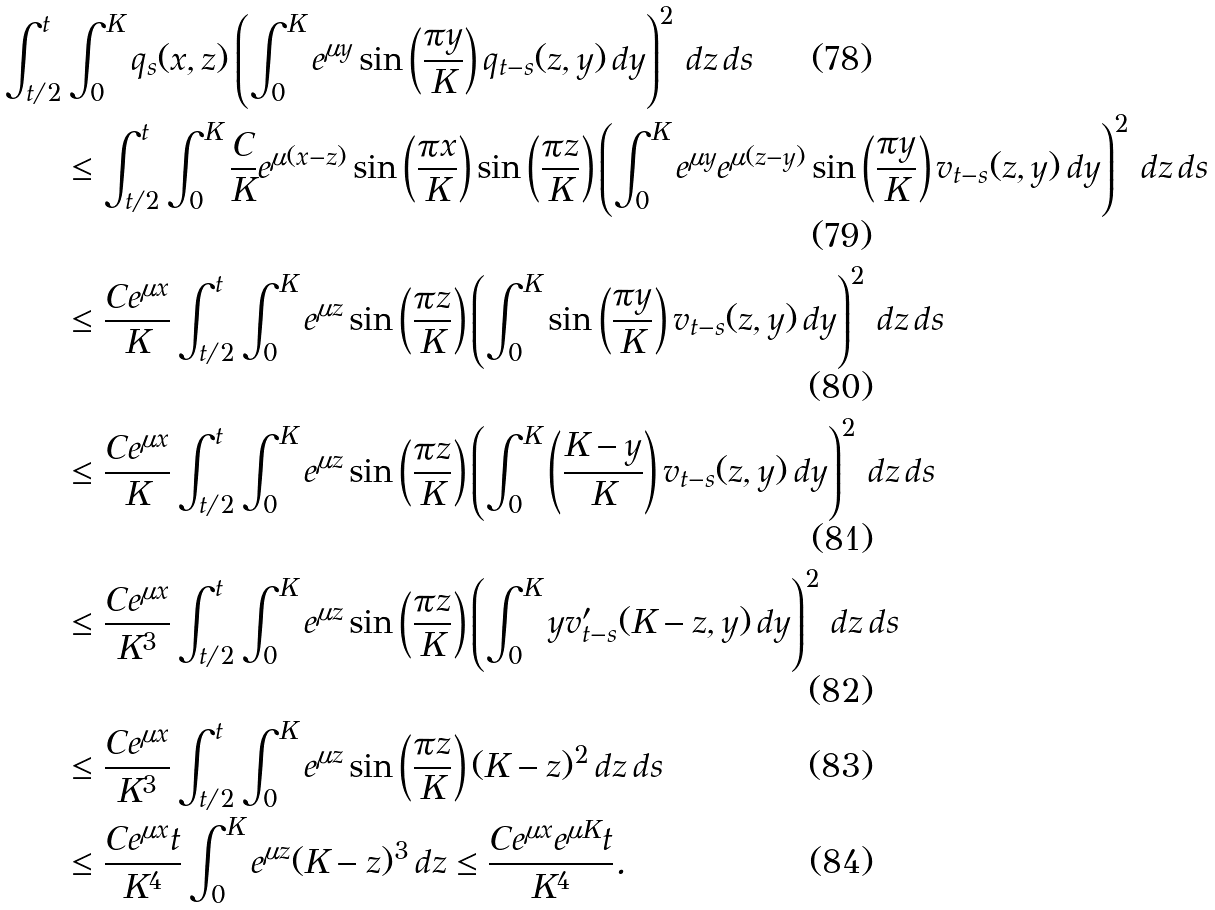Convert formula to latex. <formula><loc_0><loc_0><loc_500><loc_500>\int _ { t / 2 } ^ { t } & \int _ { 0 } ^ { K } q _ { s } ( x , z ) \left ( \int _ { 0 } ^ { K } e ^ { \mu y } \sin \left ( \frac { \pi y } { K } \right ) q _ { t - s } ( z , y ) \, d y \right ) ^ { 2 } \, d z \, d s \\ & \leq \int _ { t / 2 } ^ { t } \int _ { 0 } ^ { K } \frac { C } { K } e ^ { \mu ( x - z ) } \sin \left ( \frac { \pi x } { K } \right ) \sin \left ( \frac { \pi z } { K } \right ) \left ( \int _ { 0 } ^ { K } e ^ { \mu y } e ^ { \mu ( z - y ) } \sin \left ( \frac { \pi y } { K } \right ) v _ { t - s } ( z , y ) \, d y \right ) ^ { 2 } \, d z \, d s \\ & \leq \frac { C e ^ { \mu x } } { K } \int _ { t / 2 } ^ { t } \int _ { 0 } ^ { K } e ^ { \mu z } \sin \left ( \frac { \pi z } { K } \right ) \left ( \int _ { 0 } ^ { K } \sin \left ( \frac { \pi y } { K } \right ) v _ { t - s } ( z , y ) \, d y \right ) ^ { 2 } \, d z \, d s \\ & \leq \frac { C e ^ { \mu x } } { K } \int _ { t / 2 } ^ { t } \int _ { 0 } ^ { K } e ^ { \mu z } \sin \left ( \frac { \pi z } { K } \right ) \left ( \int _ { 0 } ^ { K } \left ( \frac { K - y } { K } \right ) v _ { t - s } ( z , y ) \, d y \right ) ^ { 2 } \, d z \, d s \\ & \leq \frac { C e ^ { \mu x } } { K ^ { 3 } } \int _ { t / 2 } ^ { t } \int _ { 0 } ^ { K } e ^ { \mu z } \sin \left ( \frac { \pi z } { K } \right ) \left ( \int _ { 0 } ^ { K } y v _ { t - s } ^ { \prime } ( K - z , y ) \, d y \right ) ^ { 2 } \, d z \, d s \\ & \leq \frac { C e ^ { \mu x } } { K ^ { 3 } } \int _ { t / 2 } ^ { t } \int _ { 0 } ^ { K } e ^ { \mu z } \sin \left ( \frac { \pi z } { K } \right ) ( K - z ) ^ { 2 } \, d z \, d s \\ & \leq \frac { C e ^ { \mu x } t } { K ^ { 4 } } \int _ { 0 } ^ { K } e ^ { \mu z } ( K - z ) ^ { 3 } \, d z \leq \frac { C e ^ { \mu x } e ^ { \mu K } t } { K ^ { 4 } } .</formula> 